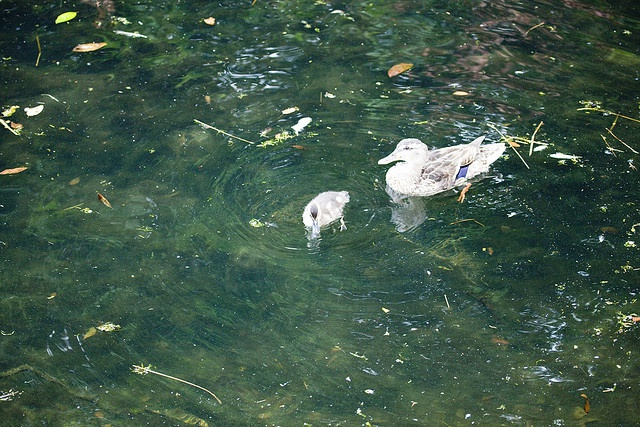Describe the objects in this image and their specific colors. I can see bird in darkgray, white, gray, and black tones and bird in darkgray, white, teal, and gray tones in this image. 